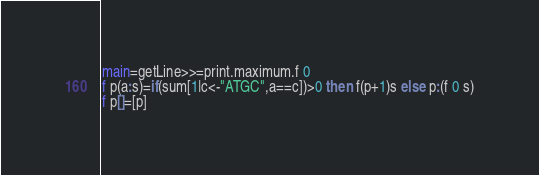<code> <loc_0><loc_0><loc_500><loc_500><_Haskell_>main=getLine>>=print.maximum.f 0
f p(a:s)=if(sum[1|c<-"ATGC",a==c])>0 then f(p+1)s else p:(f 0 s)
f p[]=[p]</code> 